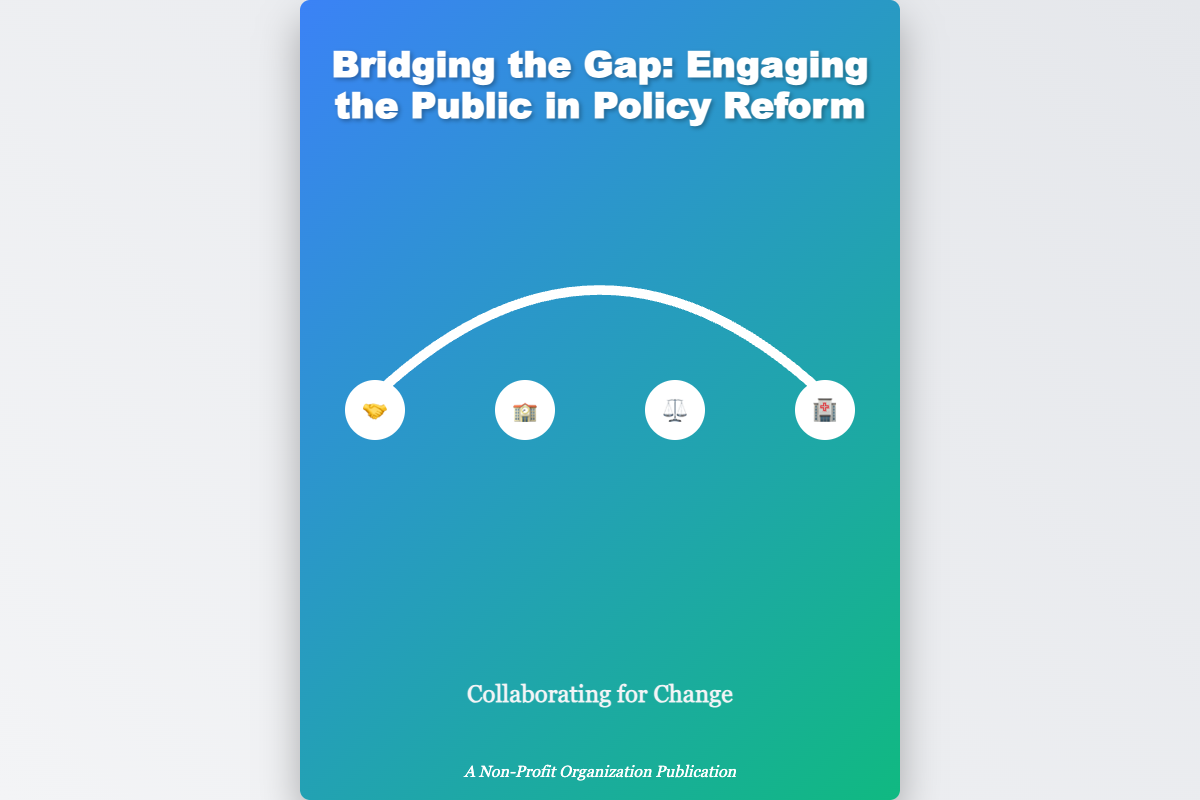What is the title of the book? The title of the book is prominently displayed at the top of the cover.
Answer: Bridging the Gap: Engaging the Public in Policy Reform What symbols are represented in the bridge? The icons depicted in the bridge include community collaboration symbols.
Answer: 🤝, 🏫, ⚖️, 🏥 What is the subtitle of the book? The subtitle is located below the title and summarizes the book’s focus.
Answer: Collaborating for Change Who published the book? The publication credit is listed at the bottom of the cover.
Answer: A Non-Profit Organization Publication What color scheme is used for the book cover? The background color gradient of the cover signifies visual engagement.
Answer: Blue and green What does the bridge symbolize in the cover art? The bridge represents the collaboration between the public and legislative bodies.
Answer: Collaboration How many icons are displayed on the bridge? The icons represent different community aspects in total on the bridge.
Answer: Four What is the main theme of the book based on the subtitle? The subtitle suggests a focus on the importance of collective efforts for policy reform.
Answer: Change 